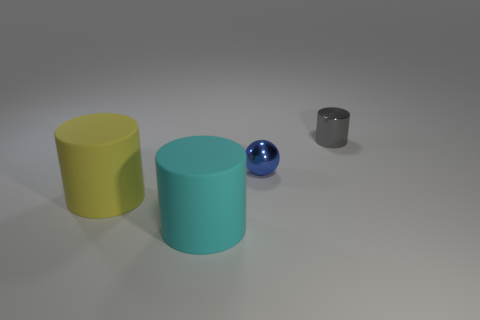Are there any large green objects made of the same material as the yellow thing?
Give a very brief answer. No. The thing that is in front of the tiny gray cylinder and behind the large yellow rubber cylinder has what shape?
Your response must be concise. Sphere. What number of other objects are the same shape as the big yellow matte object?
Offer a very short reply. 2. The blue shiny ball has what size?
Ensure brevity in your answer.  Small. How many objects are large metallic spheres or large things?
Offer a terse response. 2. What is the size of the blue shiny object in front of the tiny gray object?
Keep it short and to the point. Small. Are there any other things that have the same size as the yellow matte cylinder?
Give a very brief answer. Yes. What color is the thing that is in front of the small metal cylinder and behind the large yellow object?
Your answer should be compact. Blue. Does the big yellow object to the left of the large cyan cylinder have the same material as the large cyan object?
Give a very brief answer. Yes. There is a tiny cylinder; is it the same color as the cylinder that is in front of the yellow cylinder?
Give a very brief answer. No. 